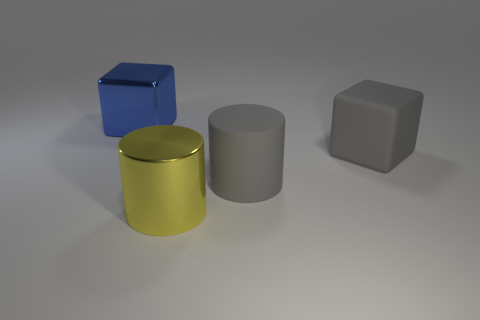Add 3 large metallic objects. How many objects exist? 7 Subtract all tiny matte cylinders. Subtract all large matte cylinders. How many objects are left? 3 Add 4 metallic things. How many metallic things are left? 6 Add 3 small blue rubber things. How many small blue rubber things exist? 3 Subtract 0 cyan spheres. How many objects are left? 4 